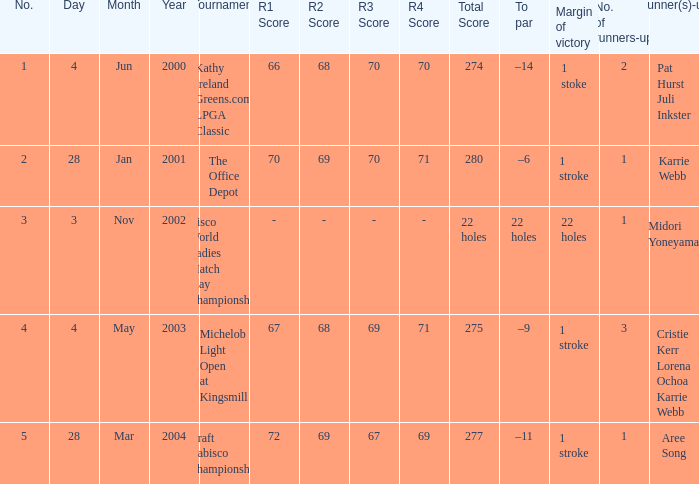Where was the tournament dated nov 3, 2002? Cisco World Ladies Match Play Championship. 